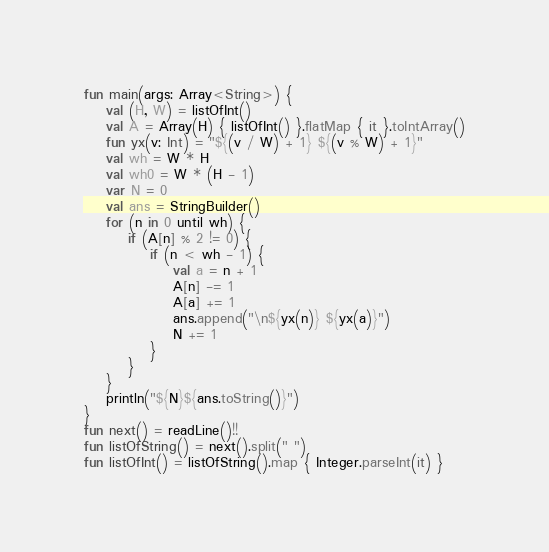<code> <loc_0><loc_0><loc_500><loc_500><_Kotlin_>fun main(args: Array<String>) {
    val (H, W) = listOfInt()
    val A = Array(H) { listOfInt() }.flatMap { it }.toIntArray()
    fun yx(v: Int) = "${(v / W) + 1} ${(v % W) + 1}"
    val wh = W * H
    val wh0 = W * (H - 1)
    var N = 0
    val ans = StringBuilder()
    for (n in 0 until wh) {
        if (A[n] % 2 != 0) {
            if (n < wh - 1) {
                val a = n + 1
                A[n] -= 1
                A[a] += 1
                ans.append("\n${yx(n)} ${yx(a)}")
                N += 1
            }
        }
    }
    println("${N}${ans.toString()}")
}
fun next() = readLine()!!
fun listOfString() = next().split(" ")
fun listOfInt() = listOfString().map { Integer.parseInt(it) }
</code> 